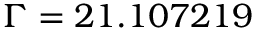<formula> <loc_0><loc_0><loc_500><loc_500>\Gamma = 2 1 . 1 0 7 2 1 9</formula> 